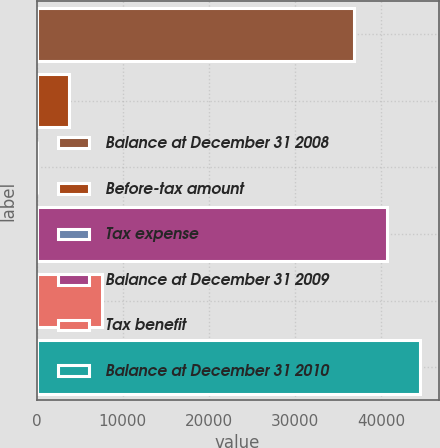<chart> <loc_0><loc_0><loc_500><loc_500><bar_chart><fcel>Balance at December 31 2008<fcel>Before-tax amount<fcel>Tax expense<fcel>Balance at December 31 2009<fcel>Tax benefit<fcel>Balance at December 31 2010<nl><fcel>36874<fcel>3815.8<fcel>9<fcel>40680.8<fcel>7622.6<fcel>44487.6<nl></chart> 